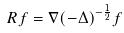<formula> <loc_0><loc_0><loc_500><loc_500>R f = \nabla ( - \Delta ) ^ { - \frac { 1 } { 2 } } f</formula> 